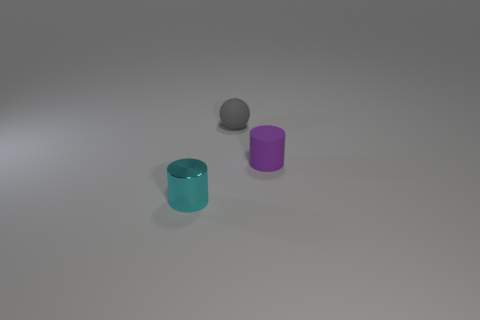How would you analyze the play of light and shadow in this image? The light source appears to be coming from the upper left side, casting a soft shadow to the opposite side of each object. The smoothness of the objects and the subtle contrast in their shadows add depth to the image, with the metallic and reflective surfaces creating a slightly more pronounced shadow than the matte one. This interplay of light and shadow could represent the way different textures interact with their environment. 